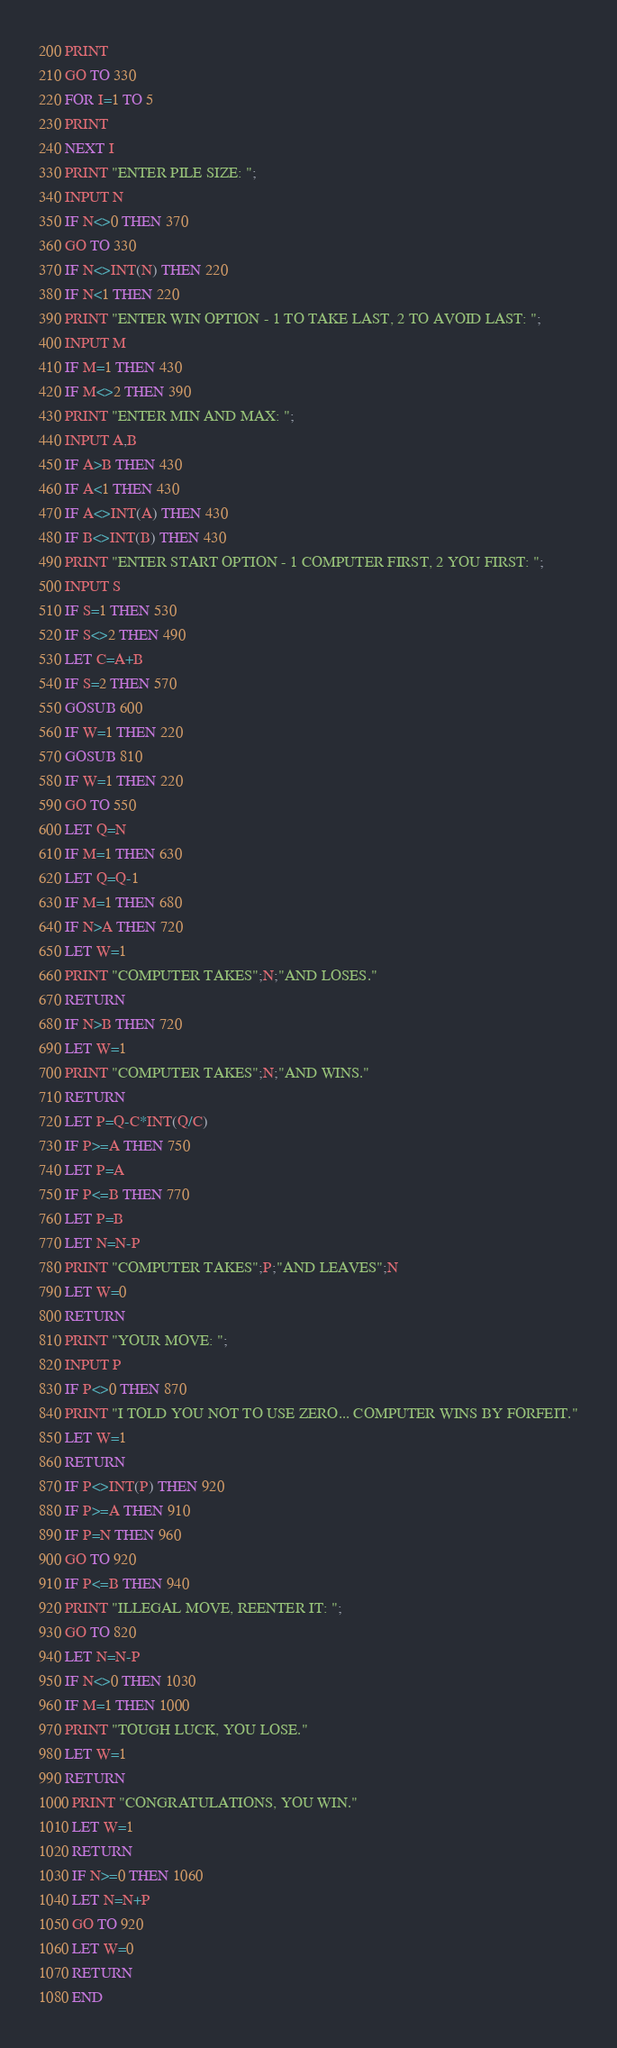Convert code to text. <code><loc_0><loc_0><loc_500><loc_500><_VisualBasic_>200 PRINT 
210 GO TO 330 
220 FOR I=1 TO 5
230 PRINT 
240 NEXT I
330 PRINT "ENTER PILE SIZE: ";
340 INPUT N
350 IF N<>0 THEN 370 
360 GO TO 330 
370 IF N<>INT(N) THEN 220 
380 IF N<1 THEN 220 
390 PRINT "ENTER WIN OPTION - 1 TO TAKE LAST, 2 TO AVOID LAST: ";
400 INPUT M
410 IF M=1 THEN 430 
420 IF M<>2 THEN 390 
430 PRINT "ENTER MIN AND MAX: ";
440 INPUT A,B
450 IF A>B THEN 430 
460 IF A<1 THEN 430 
470 IF A<>INT(A) THEN 430 
480 IF B<>INT(B) THEN 430 
490 PRINT "ENTER START OPTION - 1 COMPUTER FIRST, 2 YOU FIRST: ";
500 INPUT S
510 IF S=1 THEN 530 
520 IF S<>2 THEN 490 
530 LET C=A+B
540 IF S=2 THEN 570 
550 GOSUB 600 
560 IF W=1 THEN 220 
570 GOSUB 810 
580 IF W=1 THEN 220 
590 GO TO 550 
600 LET Q=N
610 IF M=1 THEN 630 
620 LET Q=Q-1
630 IF M=1 THEN 680 
640 IF N>A THEN 720 
650 LET W=1
660 PRINT "COMPUTER TAKES";N;"AND LOSES."
670 RETURN
680 IF N>B THEN 720 
690 LET W=1
700 PRINT "COMPUTER TAKES";N;"AND WINS."
710 RETURN
720 LET P=Q-C*INT(Q/C)
730 IF P>=A THEN 750 
740 LET P=A
750 IF P<=B THEN 770 
760 LET P=B
770 LET N=N-P
780 PRINT "COMPUTER TAKES";P;"AND LEAVES";N
790 LET W=0
800 RETURN
810 PRINT "YOUR MOVE: ";
820 INPUT P
830 IF P<>0 THEN 870 
840 PRINT "I TOLD YOU NOT TO USE ZERO... COMPUTER WINS BY FORFEIT."
850 LET W=1
860 RETURN
870 IF P<>INT(P) THEN 920 
880 IF P>=A THEN 910 
890 IF P=N THEN 960 
900 GO TO 920 
910 IF P<=B THEN 940 
920 PRINT "ILLEGAL MOVE, REENTER IT: ";
930 GO TO 820 
940 LET N=N-P
950 IF N<>0 THEN 1030 
960 IF M=1 THEN 1000 
970 PRINT "TOUGH LUCK, YOU LOSE."
980 LET W=1
990 RETURN
1000 PRINT "CONGRATULATIONS, YOU WIN."
1010 LET W=1
1020 RETURN
1030 IF N>=0 THEN 1060 
1040 LET N=N+P
1050 GO TO 920 
1060 LET W=0
1070 RETURN
1080 END
</code> 